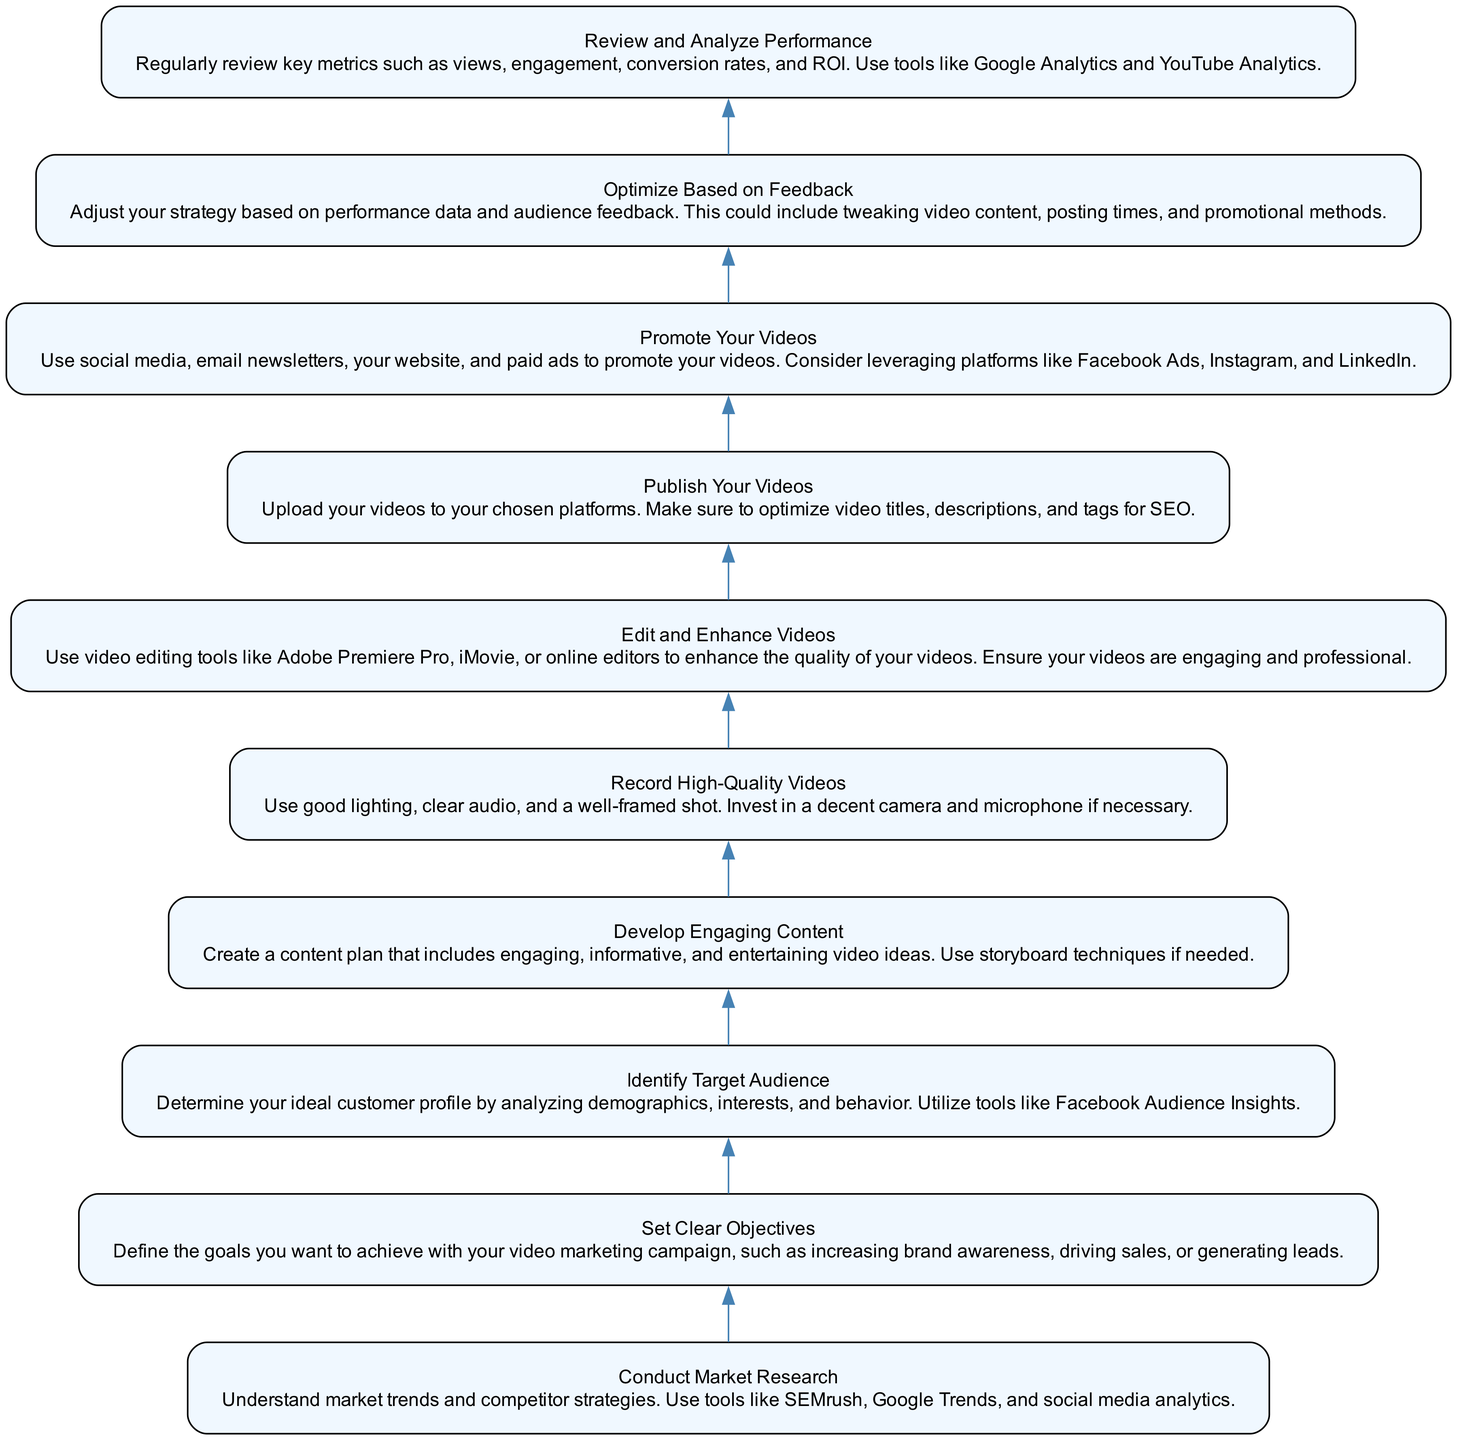What is the first step in the video marketing campaign? The first step is "Conduct Market Research". This is the bottom-most node in the flowchart, indicating it is the starting point of the process.
Answer: Conduct Market Research How many total nodes are in the diagram? By counting the individual steps reflected in each node of the diagram, there are 10 nodes listed.
Answer: 10 What step follows "Set Clear Objectives"? The next step after "Set Clear Objectives" is "Identify Target Audience", as indicated in the flow linkage between these two nodes.
Answer: Identify Target Audience Which step involves enhancing video quality? The step that involves enhancing video quality is "Edit and Enhance Videos". This is a clear action item listed in the flowchart.
Answer: Edit and Enhance Videos What is the final step in the video marketing campaign? The final step is "Review and Analyze Performance". It is shown at the top of the flowchart, reflecting it as a concluding action in the campaign process.
Answer: Review and Analyze Performance If your audience isn't responding well, which step should you revisit? You should revisit "Optimize Based on Feedback". This step indicates that adjustments should be made based on performance data and feedback from the audience.
Answer: Optimize Based on Feedback What directly precedes "Publish Your Videos"? "Edit and Enhance Videos" is the step that directly precedes "Publish Your Videos", logically showing the order of operations in the diagram.
Answer: Edit and Enhance Videos What step involves determining your ideal customer profile? The step that involves determining your ideal customer profile is "Identify Target Audience". This emphasizes the importance of knowing your audience in the marketing process.
Answer: Identify Target Audience Which tools are suggested for analyzing performance? The suggested tools for analyzing performance are "Google Analytics" and "YouTube Analytics", mentioned in the context of reviewing key metrics.
Answer: Google Analytics and YouTube Analytics 